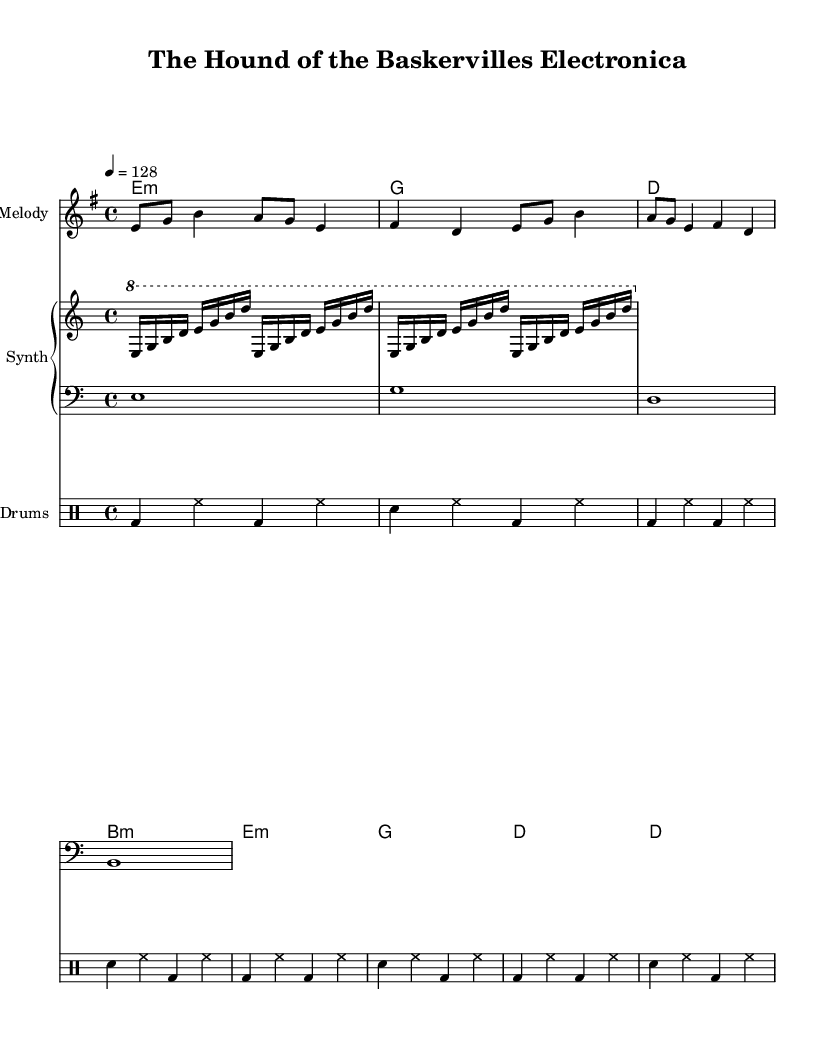What is the key signature of this music? The key signature indicates the notes that are sharp or flat. Here, the key signature is e minor, as it contains one sharp (F#).
Answer: e minor What is the time signature of this piece? The time signature appears at the beginning of the score, indicating the number of beats per measure. The time signature is 4/4, which means there are four beats in each measure.
Answer: 4/4 What is the tempo marked in this score? The tempo marking indicates how fast the piece should be played. The tempo is set at quarter note = 128 beats per minute.
Answer: 128 How many different instruments are included in this score? Counting the distinct parts in the score, there are four: Melody, Synth (with both arpeggiator and bass parts), and Drums.
Answer: Four What is the first chord in the harmony? The first chord in the harmony section is indicated by the chord names above the staff. The first chord shown is e minor.
Answer: e minor How many times is the bass note e played in the score? The bass part shows the notes played, and we can count that the note e is played once in each measure of the four measures, totaling four occurrences.
Answer: Four What is the primary rhythmic pattern used in the drum section? The drum patterns are clearly defined in the drummode section, where the rhythm alternates between bass drum and snare drum in repeated measures. The primary pattern consists of a bass drum followed by a snare in a 4/4 time.
Answer: Bass and snare 